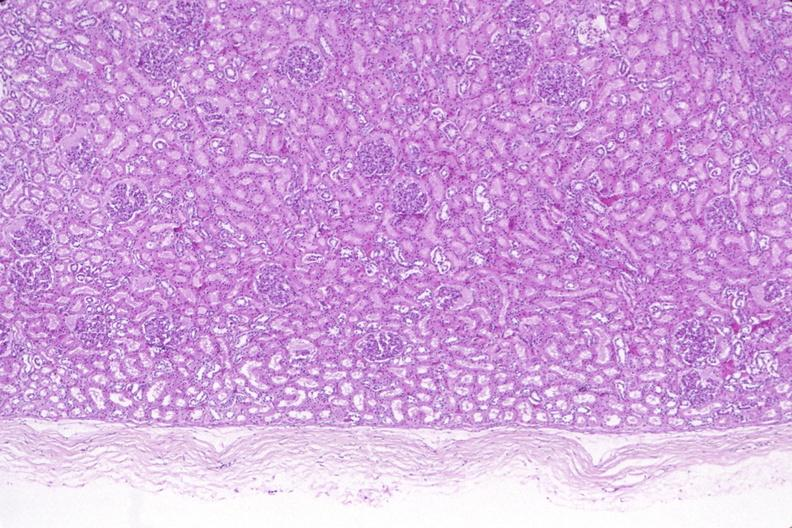what does this image show?
Answer the question using a single word or phrase. Kidney 